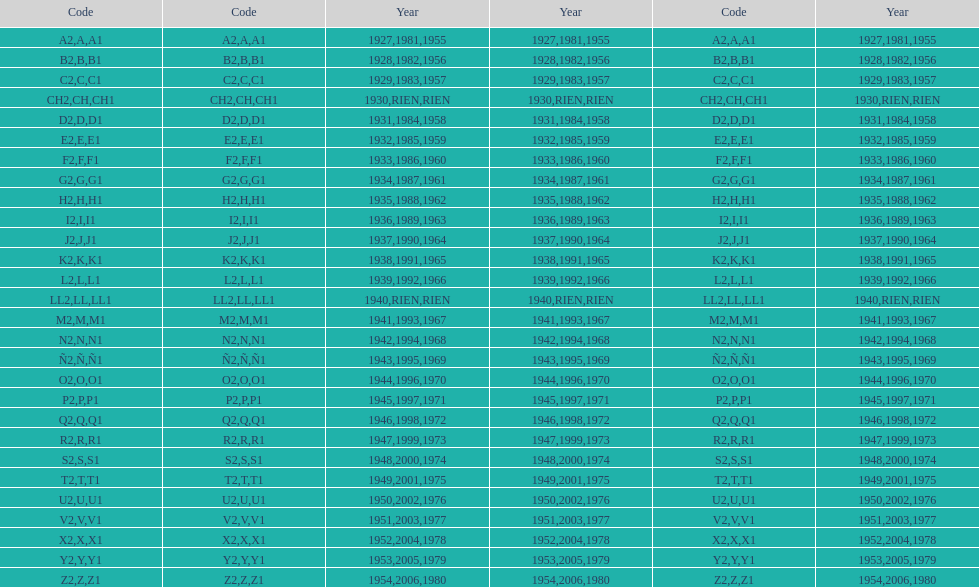Could you parse the entire table as a dict? {'header': ['Code', 'Code', 'Year', 'Year', 'Code', 'Year'], 'rows': [['A2', 'A', '1927', '1981', 'A1', '1955'], ['B2', 'B', '1928', '1982', 'B1', '1956'], ['C2', 'C', '1929', '1983', 'C1', '1957'], ['CH2', 'CH', '1930', 'RIEN', 'CH1', 'RIEN'], ['D2', 'D', '1931', '1984', 'D1', '1958'], ['E2', 'E', '1932', '1985', 'E1', '1959'], ['F2', 'F', '1933', '1986', 'F1', '1960'], ['G2', 'G', '1934', '1987', 'G1', '1961'], ['H2', 'H', '1935', '1988', 'H1', '1962'], ['I2', 'I', '1936', '1989', 'I1', '1963'], ['J2', 'J', '1937', '1990', 'J1', '1964'], ['K2', 'K', '1938', '1991', 'K1', '1965'], ['L2', 'L', '1939', '1992', 'L1', '1966'], ['LL2', 'LL', '1940', 'RIEN', 'LL1', 'RIEN'], ['M2', 'M', '1941', '1993', 'M1', '1967'], ['N2', 'N', '1942', '1994', 'N1', '1968'], ['Ñ2', 'Ñ', '1943', '1995', 'Ñ1', '1969'], ['O2', 'O', '1944', '1996', 'O1', '1970'], ['P2', 'P', '1945', '1997', 'P1', '1971'], ['Q2', 'Q', '1946', '1998', 'Q1', '1972'], ['R2', 'R', '1947', '1999', 'R1', '1973'], ['S2', 'S', '1948', '2000', 'S1', '1974'], ['T2', 'T', '1949', '2001', 'T1', '1975'], ['U2', 'U', '1950', '2002', 'U1', '1976'], ['V2', 'V', '1951', '2003', 'V1', '1977'], ['X2', 'X', '1952', '2004', 'X1', '1978'], ['Y2', 'Y', '1953', '2005', 'Y1', '1979'], ['Z2', 'Z', '1954', '2006', 'Z1', '1980']]} Number of codes containing a 2? 28. 